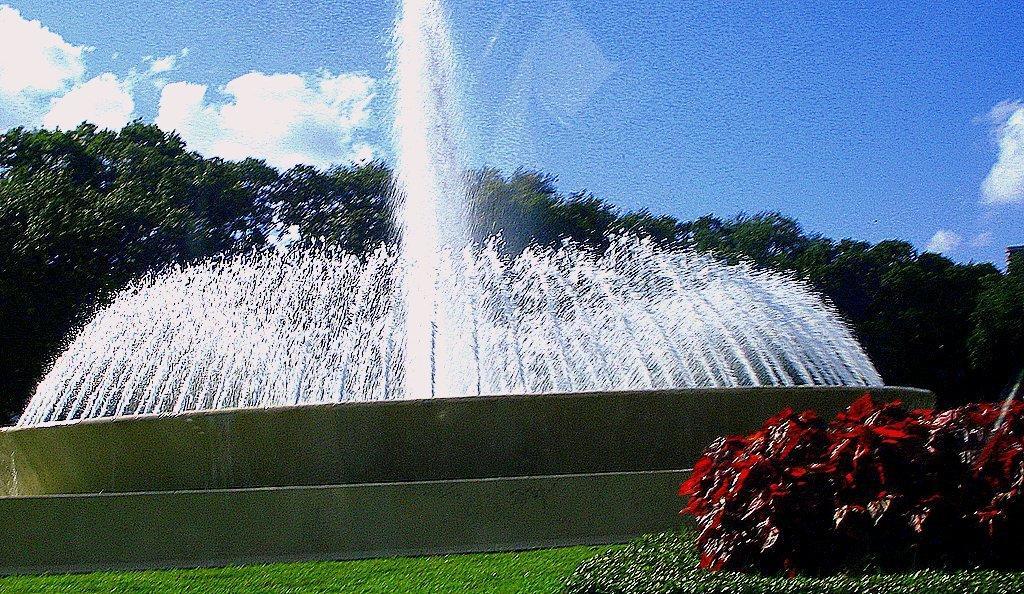Describe this image in one or two sentences. There are plants and grassland at the bottom side of the image, there is a fountain in the center. There are trees and the sky in the background. 